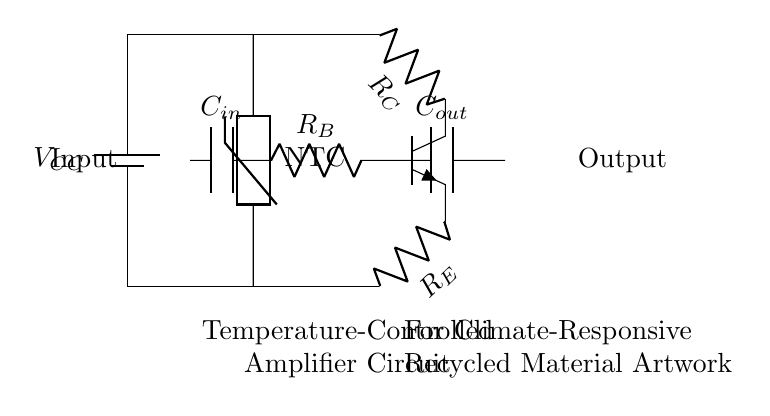What is the type of transistor used in the circuit? The transistor is designated as npn in the diagram. It is shown connected at the center of the circuit, with pins denoting collector, emitter, and base.
Answer: npn What does NTC stand for in the temperature sensor? NTC stands for Negative Temperature Coefficient, indicating that the resistance decreases with an increase in temperature. This can be inferred from the labeling on the temperature sensor in the circuit.
Answer: Negative Temperature Coefficient How many resistors are present in this circuit? The diagram shows three resistors labeled as R_C, R_E, and R_B. By counting the labeled components in the circuit, the total number of resistors can be determined.
Answer: three What is the function of the capacitor labeled C_out? The C_out capacitor serves to filter or smooth the output signal from the amplifier, ensuring that the output voltage is stable. This understanding comes from the typical role of capacitors in amplifier circuits, particularly in output stages.
Answer: Smoothing output signal What is the role of the thermistor in this circuit? The thermistor acts as a temperature sensor that influences the amplifier's behavior according to temperature changes. As it detects temperature variations, its resistance will change, affecting the circuit's performance.
Answer: Temperature sensor Which component is responsible for temperature sensitivity in the circuit? The temperature sensitivity is provided by the NTC thermistor, which responds to temperature changes, altering its resistance. This can be seen in the circuit where the thermistor is connected.
Answer: NTC thermistor How does the amplifier output respond to increasing temperature? As temperature increases, the NTC thermistor's resistance decreases, allowing more current to flow into the base of the transistor, thus increasing the output amplification. This results from analyzing the behavior of the thermistor and its influence on the transistor.
Answer: Increases amplification 